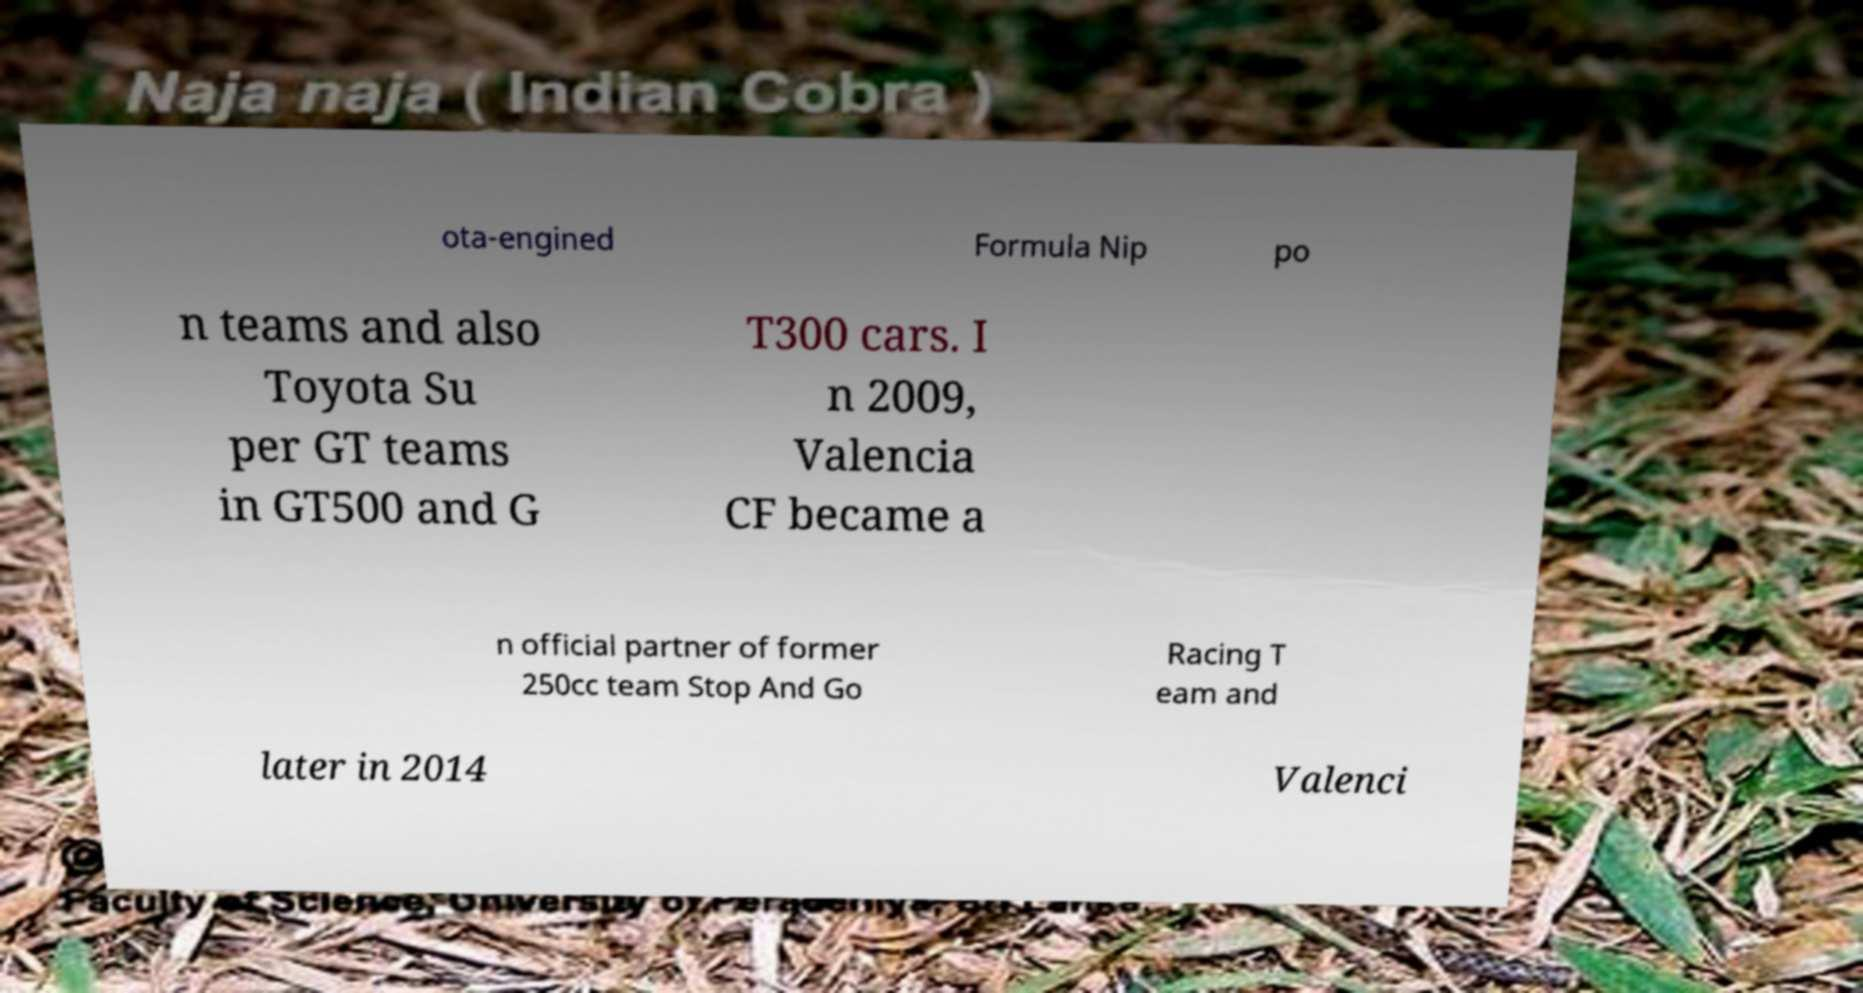Could you assist in decoding the text presented in this image and type it out clearly? ota-engined Formula Nip po n teams and also Toyota Su per GT teams in GT500 and G T300 cars. I n 2009, Valencia CF became a n official partner of former 250cc team Stop And Go Racing T eam and later in 2014 Valenci 